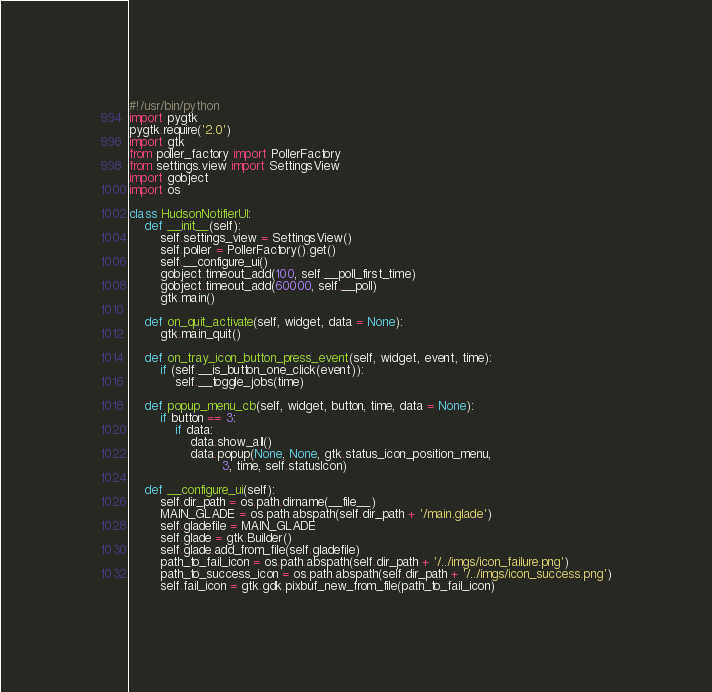Convert code to text. <code><loc_0><loc_0><loc_500><loc_500><_Python_>#!/usr/bin/python
import pygtk
pygtk.require('2.0')
import gtk
from poller_factory import PollerFactory
from settings.view import SettingsView
import gobject
import os

class HudsonNotifierUI:
	def __init__(self):
		self.settings_view = SettingsView()
		self.poller = PollerFactory().get()
		self.__configure_ui()
		gobject.timeout_add(100, self.__poll_first_time)
		gobject.timeout_add(60000, self.__poll)
		gtk.main()

	def on_quit_activate(self, widget, data = None):
		gtk.main_quit()

	def on_tray_icon_button_press_event(self, widget, event, time):
		if (self.__is_button_one_click(event)):
			self.__toggle_jobs(time)

	def popup_menu_cb(self, widget, button, time, data = None):
		if button == 3:
			if data:
				data.show_all()
				data.popup(None, None, gtk.status_icon_position_menu,
						3, time, self.statusIcon)

	def __configure_ui(self):
		self.dir_path = os.path.dirname(__file__)
		MAIN_GLADE = os.path.abspath(self.dir_path + '/main.glade')
		self.gladefile = MAIN_GLADE
		self.glade = gtk.Builder()
		self.glade.add_from_file(self.gladefile)
		path_to_fail_icon = os.path.abspath(self.dir_path + '/../imgs/icon_failure.png')
		path_to_success_icon = os.path.abspath(self.dir_path + '/../imgs/icon_success.png')
		self.fail_icon = gtk.gdk.pixbuf_new_from_file(path_to_fail_icon)</code> 